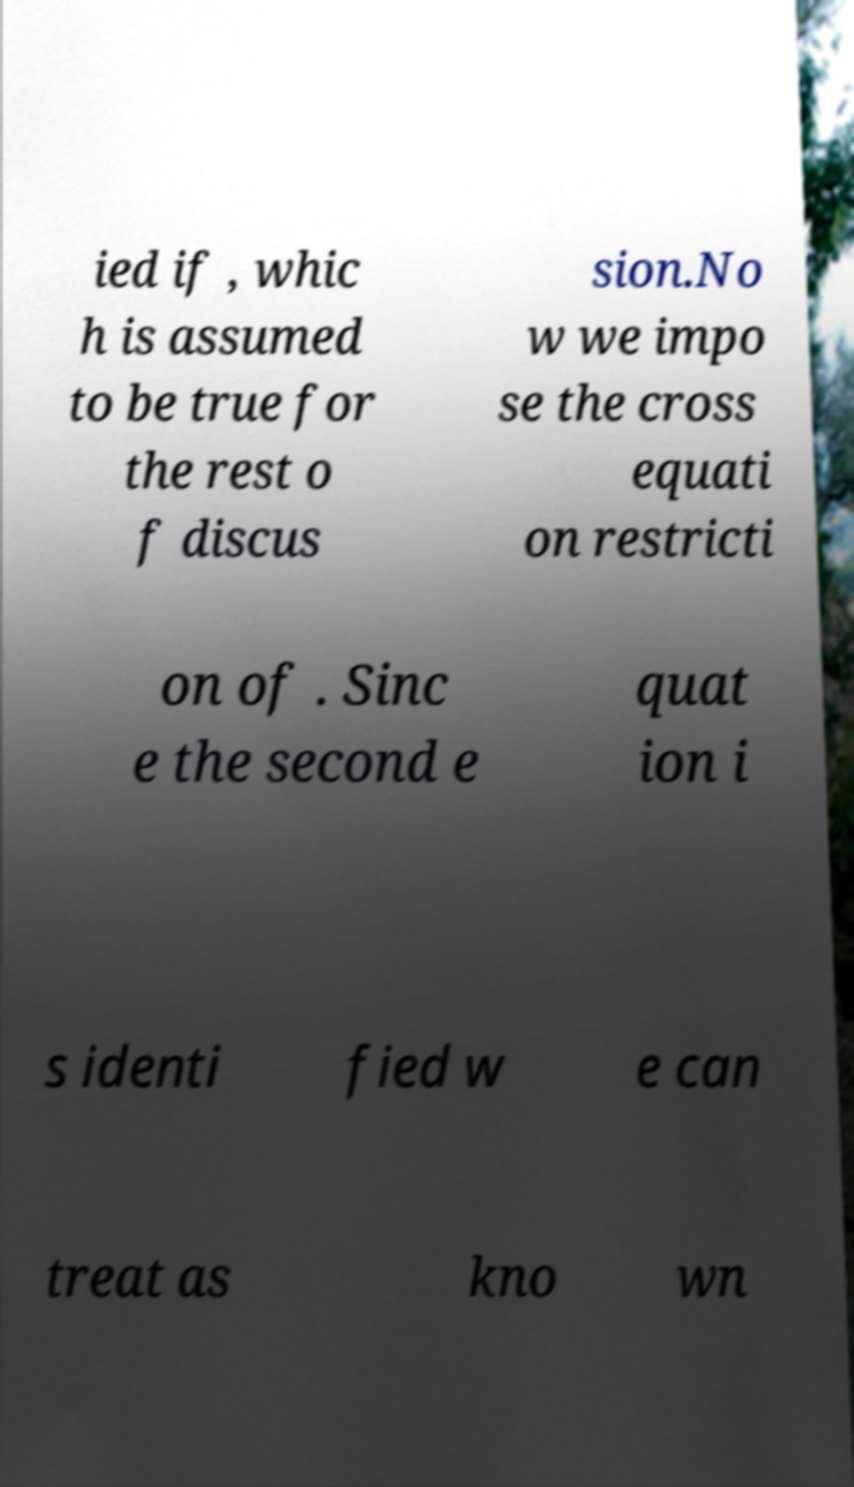Could you extract and type out the text from this image? ied if , whic h is assumed to be true for the rest o f discus sion.No w we impo se the cross equati on restricti on of . Sinc e the second e quat ion i s identi fied w e can treat as kno wn 